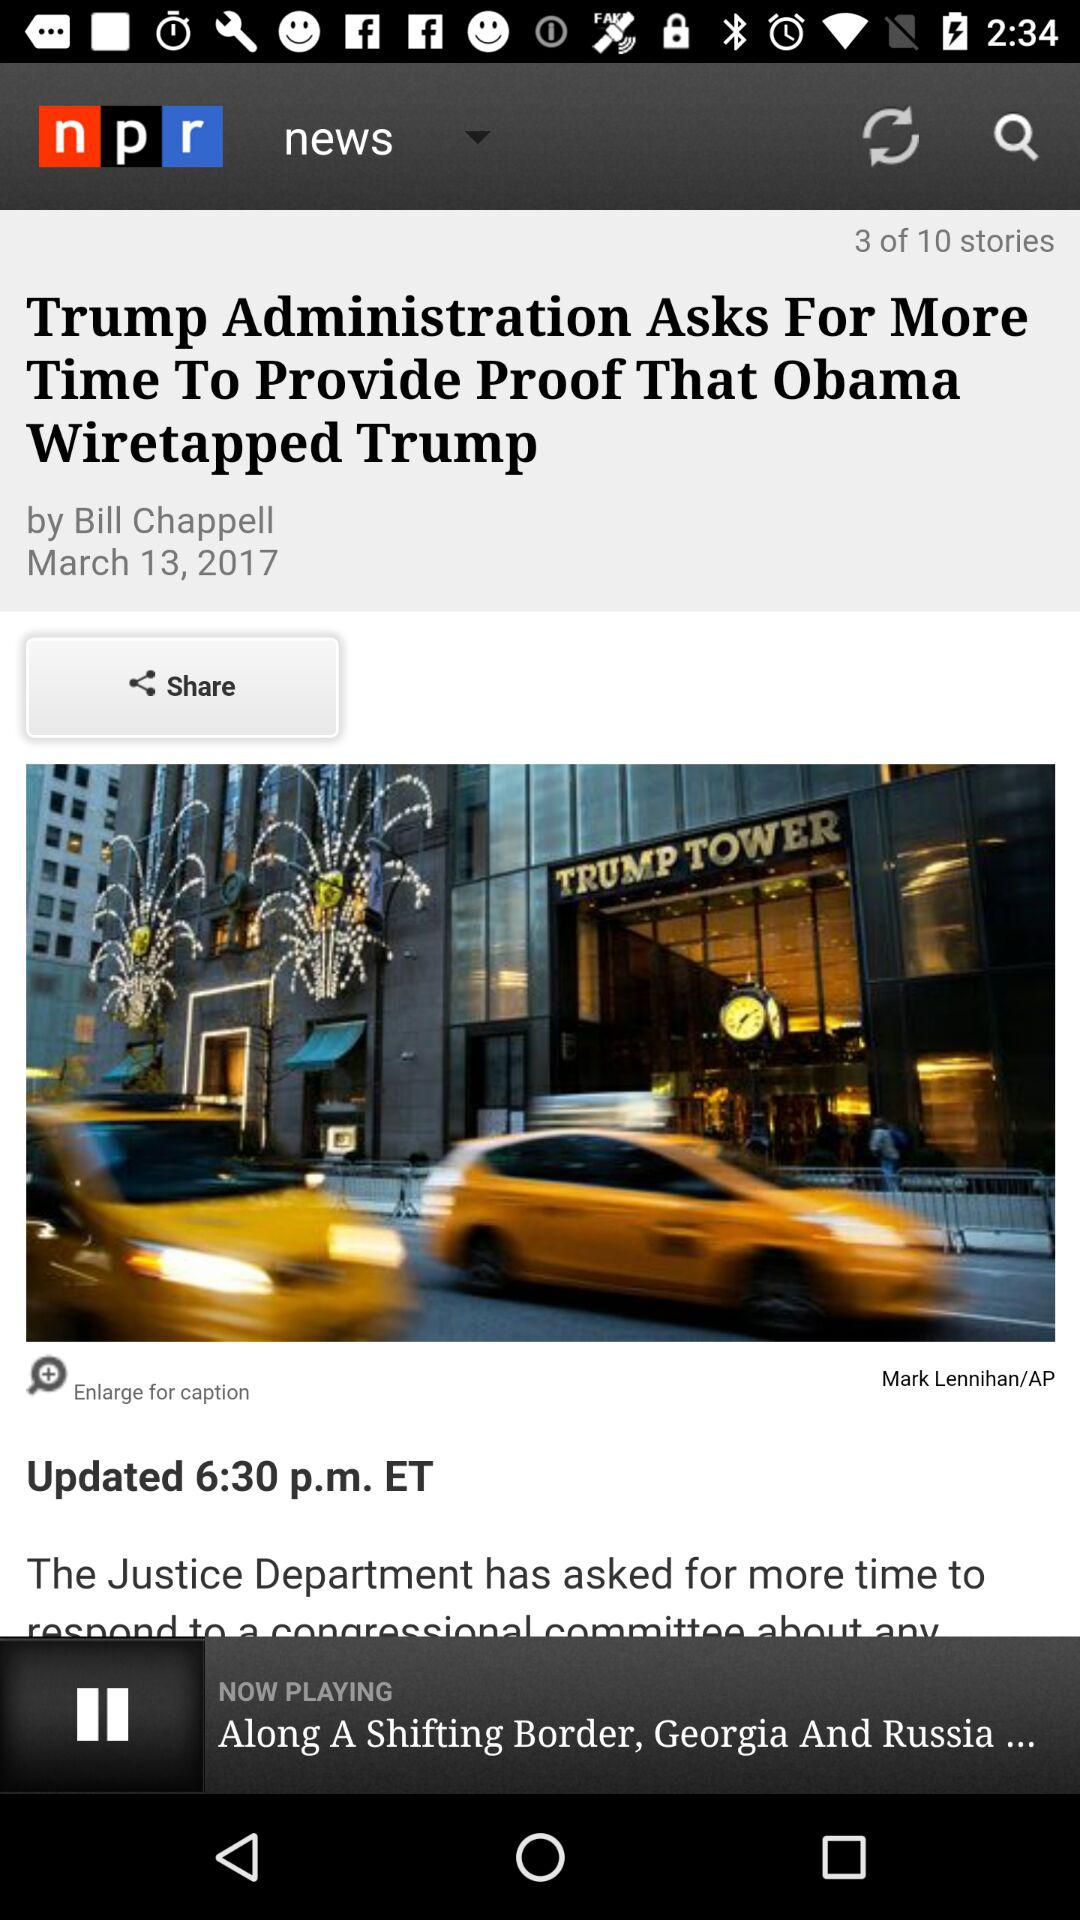When was the article published? The article was published on March 13, 2017. 